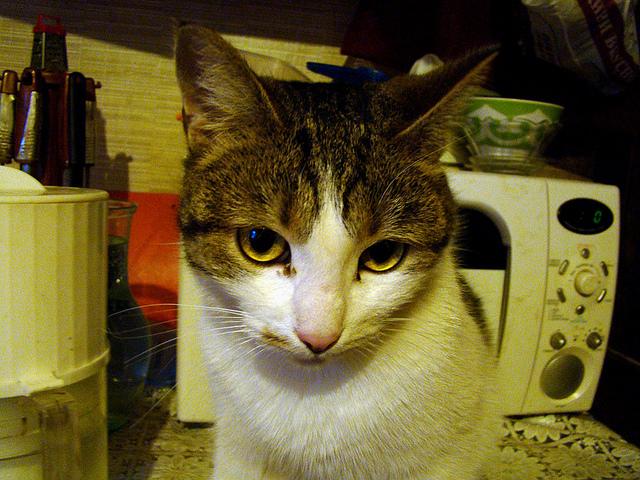What is the number on the microwave?
Keep it brief. 0. What is that cloth under the microwave called?
Write a very short answer. Doily. What color is the cat's nose?
Quick response, please. Pink. What's in the bottle?
Quick response, please. Water. How many stripes are on the cats faces?
Answer briefly. 3. What color are the cats eyes?
Concise answer only. Yellow. 